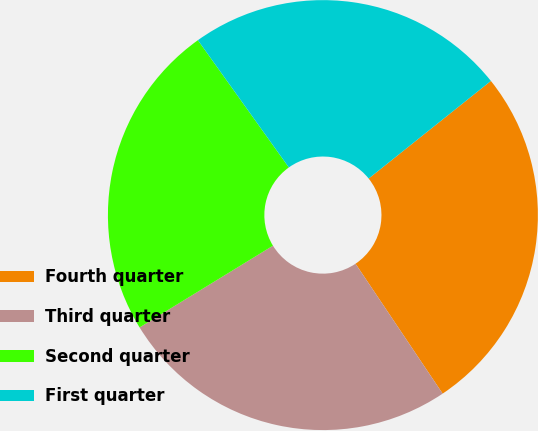Convert chart. <chart><loc_0><loc_0><loc_500><loc_500><pie_chart><fcel>Fourth quarter<fcel>Third quarter<fcel>Second quarter<fcel>First quarter<nl><fcel>26.32%<fcel>25.65%<fcel>23.87%<fcel>24.15%<nl></chart> 